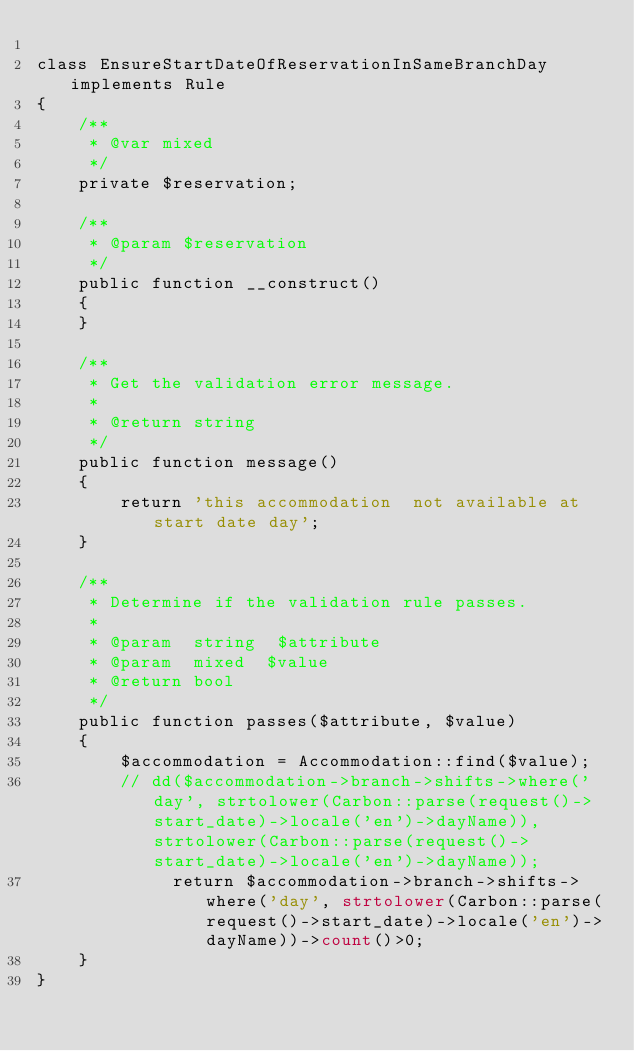<code> <loc_0><loc_0><loc_500><loc_500><_PHP_>
class EnsureStartDateOfReservationInSameBranchDay implements Rule
{
    /**
     * @var mixed
     */
    private $reservation;

    /**
     * @param $reservation
     */
    public function __construct()
    {
    }

    /**
     * Get the validation error message.
     *
     * @return string
     */
    public function message()
    {
        return 'this accommodation  not available at start date day';
    }

    /**
     * Determine if the validation rule passes.
     *
     * @param  string  $attribute
     * @param  mixed  $value
     * @return bool
     */
    public function passes($attribute, $value)
    {
        $accommodation = Accommodation::find($value);
        // dd($accommodation->branch->shifts->where('day', strtolower(Carbon::parse(request()->start_date)->locale('en')->dayName)),strtolower(Carbon::parse(request()->start_date)->locale('en')->dayName));
             return $accommodation->branch->shifts->where('day', strtolower(Carbon::parse(request()->start_date)->locale('en')->dayName))->count()>0;
    }
}
</code> 